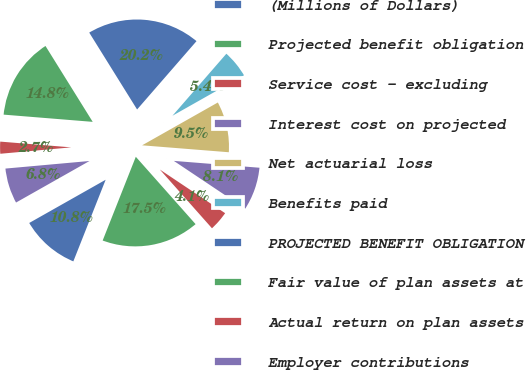Convert chart. <chart><loc_0><loc_0><loc_500><loc_500><pie_chart><fcel>(Millions of Dollars)<fcel>Projected benefit obligation<fcel>Service cost - excluding<fcel>Interest cost on projected<fcel>Net actuarial loss<fcel>Benefits paid<fcel>PROJECTED BENEFIT OBLIGATION<fcel>Fair value of plan assets at<fcel>Actual return on plan assets<fcel>Employer contributions<nl><fcel>10.81%<fcel>17.55%<fcel>4.07%<fcel>8.11%<fcel>9.46%<fcel>5.42%<fcel>20.25%<fcel>14.85%<fcel>2.72%<fcel>6.76%<nl></chart> 